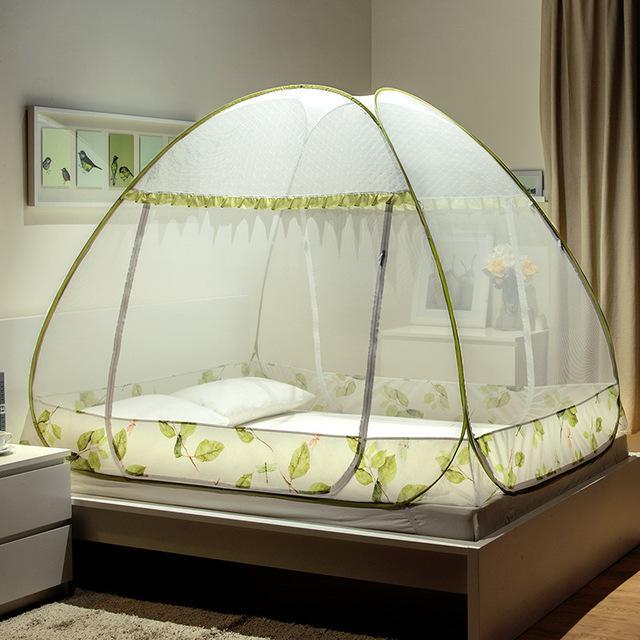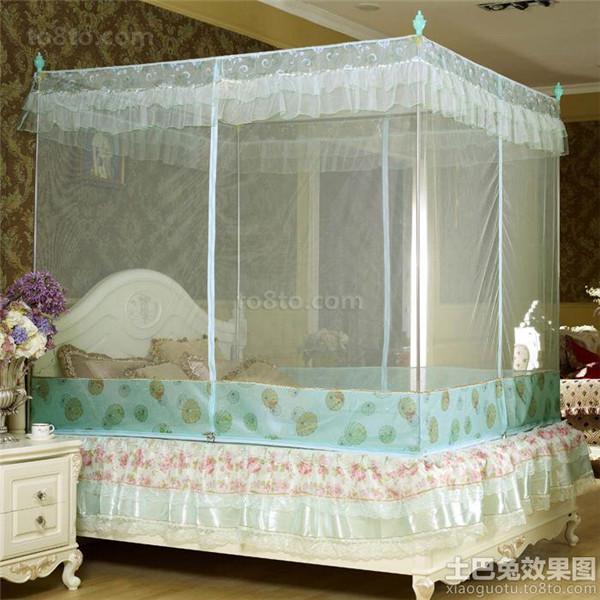The first image is the image on the left, the second image is the image on the right. Examine the images to the left and right. Is the description "In the image to the left, the bed canopy is closed." accurate? Answer yes or no. Yes. The first image is the image on the left, the second image is the image on the right. Assess this claim about the two images: "The bed covering in one image is igloo shaped with green ribbing details.". Correct or not? Answer yes or no. Yes. 